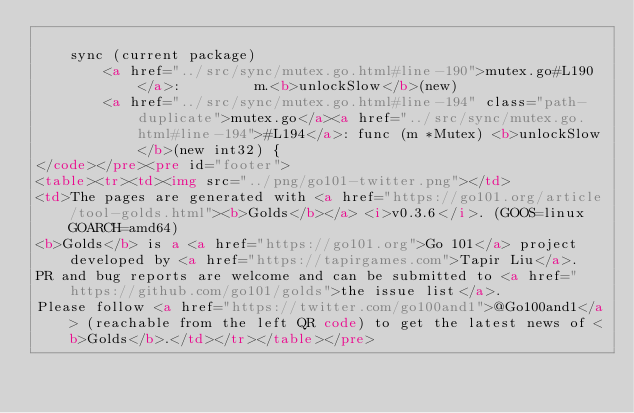<code> <loc_0><loc_0><loc_500><loc_500><_HTML_>
	sync (current package)
		<a href="../src/sync/mutex.go.html#line-190">mutex.go#L190</a>: 		m.<b>unlockSlow</b>(new)
		<a href="../src/sync/mutex.go.html#line-194" class="path-duplicate">mutex.go</a><a href="../src/sync/mutex.go.html#line-194">#L194</a>: func (m *Mutex) <b>unlockSlow</b>(new int32) {
</code></pre><pre id="footer">
<table><tr><td><img src="../png/go101-twitter.png"></td>
<td>The pages are generated with <a href="https://go101.org/article/tool-golds.html"><b>Golds</b></a> <i>v0.3.6</i>. (GOOS=linux GOARCH=amd64)
<b>Golds</b> is a <a href="https://go101.org">Go 101</a> project developed by <a href="https://tapirgames.com">Tapir Liu</a>.
PR and bug reports are welcome and can be submitted to <a href="https://github.com/go101/golds">the issue list</a>.
Please follow <a href="https://twitter.com/go100and1">@Go100and1</a> (reachable from the left QR code) to get the latest news of <b>Golds</b>.</td></tr></table></pre></code> 